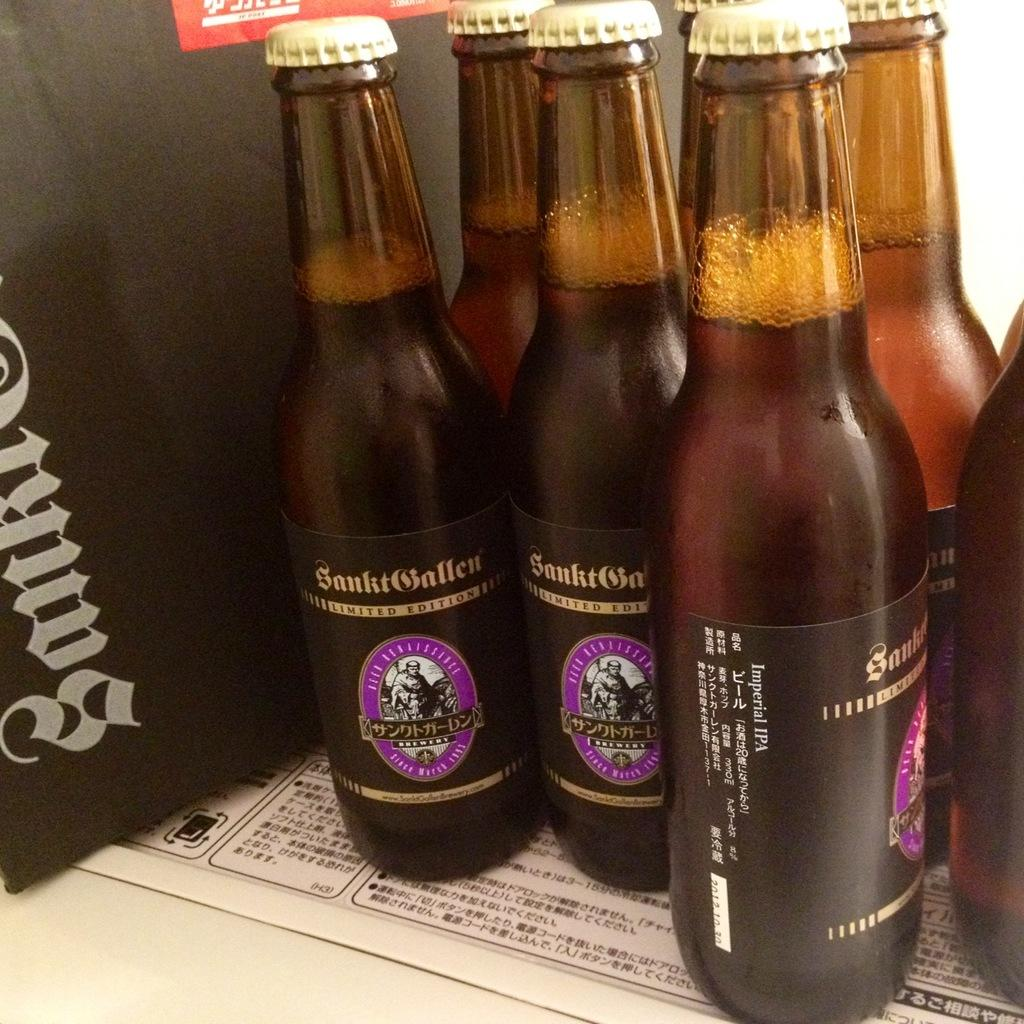<image>
Present a compact description of the photo's key features. Three bottles of limited edition beer from a japanese brewery. 